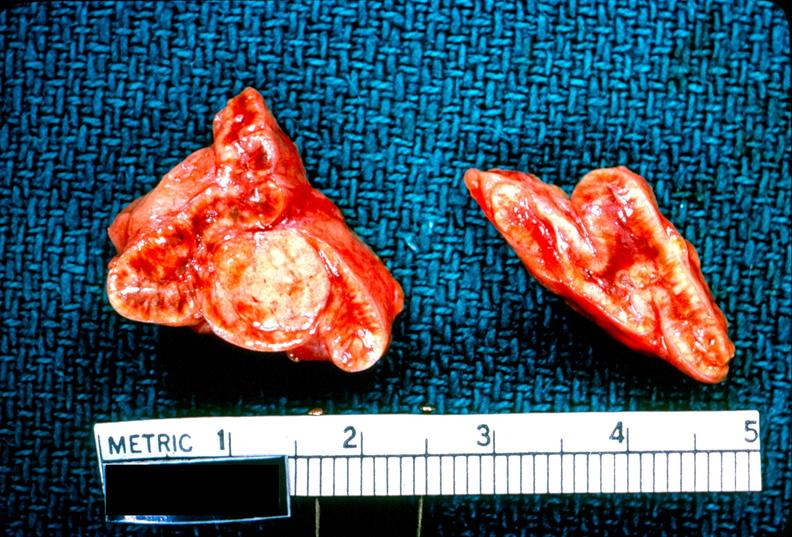where does this belong to?
Answer the question using a single word or phrase. Endocrine system 